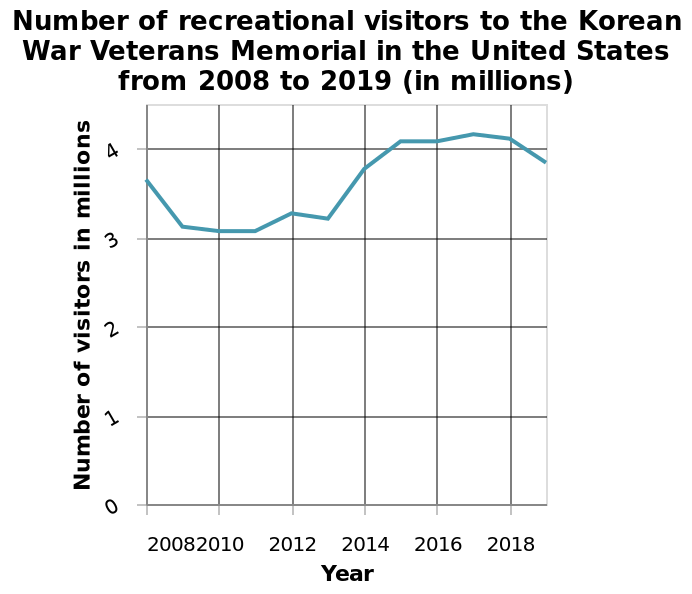<image>
What information does the x-axis represent? The x-axis represents the years from 2008 to 2019. Describe the following image in detail This is a line graph named Number of recreational visitors to the Korean War Veterans Memorial in the United States from 2008 to 2019 (in millions). The y-axis plots Number of visitors in millions while the x-axis shows Year. 